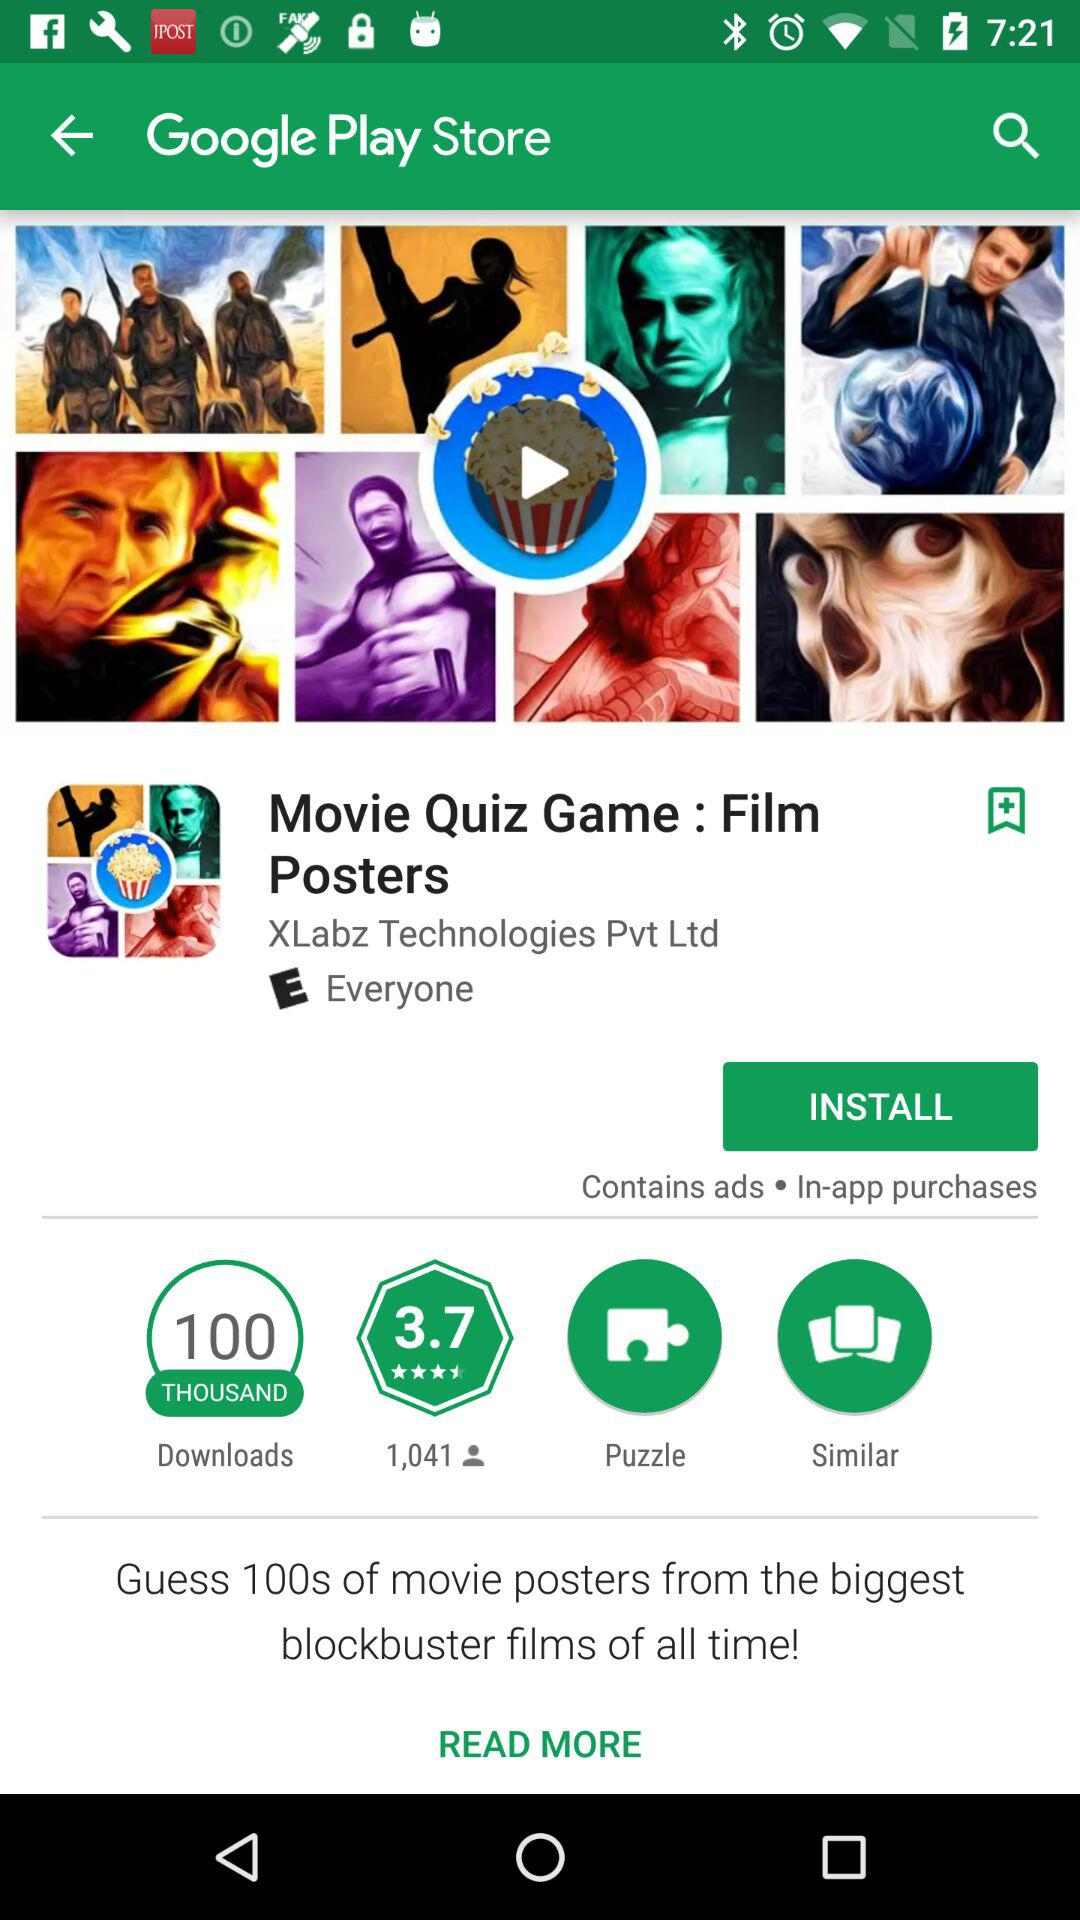What is the rating of the "Movie Quiz Game : Film Posters" application? The rating is 3.7 stars. 